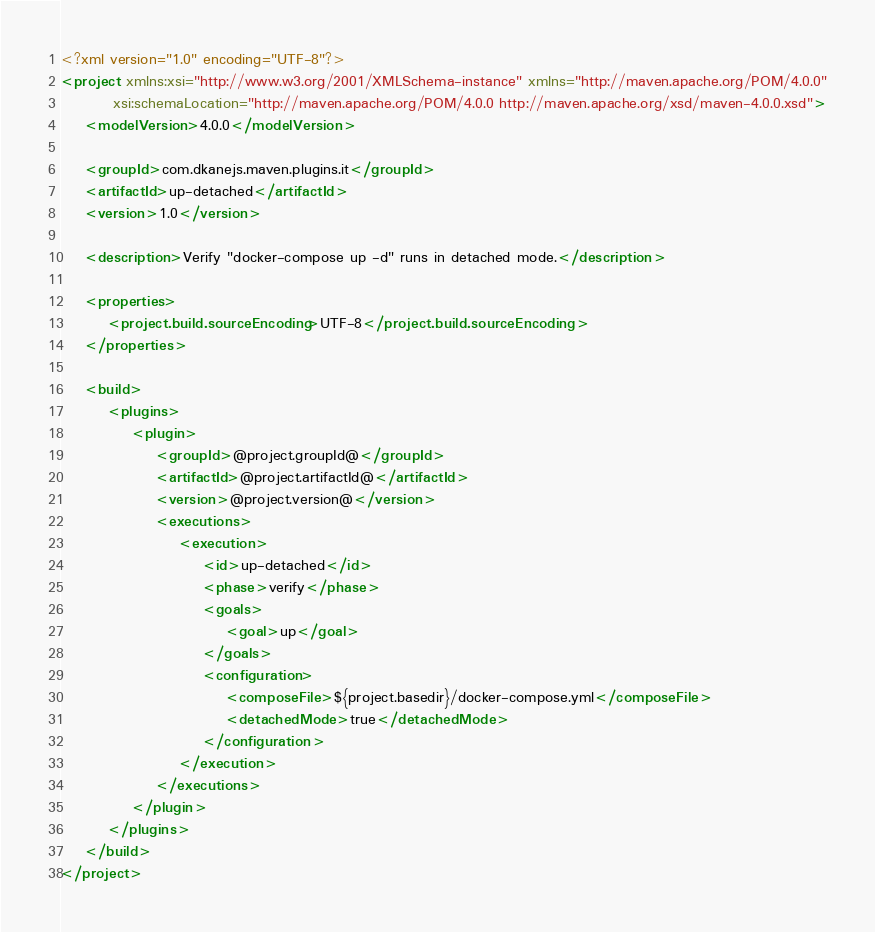Convert code to text. <code><loc_0><loc_0><loc_500><loc_500><_XML_><?xml version="1.0" encoding="UTF-8"?>
<project xmlns:xsi="http://www.w3.org/2001/XMLSchema-instance" xmlns="http://maven.apache.org/POM/4.0.0"
         xsi:schemaLocation="http://maven.apache.org/POM/4.0.0 http://maven.apache.org/xsd/maven-4.0.0.xsd">
    <modelVersion>4.0.0</modelVersion>

    <groupId>com.dkanejs.maven.plugins.it</groupId>
    <artifactId>up-detached</artifactId>
    <version>1.0</version>

    <description>Verify "docker-compose up -d" runs in detached mode.</description>

    <properties>
        <project.build.sourceEncoding>UTF-8</project.build.sourceEncoding>
    </properties>

    <build>
        <plugins>
            <plugin>
                <groupId>@project.groupId@</groupId>
                <artifactId>@project.artifactId@</artifactId>
                <version>@project.version@</version>
                <executions>
                    <execution>
                        <id>up-detached</id>
                        <phase>verify</phase>
                        <goals>
                            <goal>up</goal>
                        </goals>
                        <configuration>
                            <composeFile>${project.basedir}/docker-compose.yml</composeFile>
                            <detachedMode>true</detachedMode>
                        </configuration>
                    </execution>
                </executions>
            </plugin>
        </plugins>
    </build>
</project>
</code> 